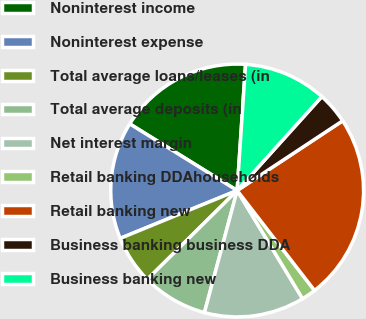Convert chart to OTSL. <chart><loc_0><loc_0><loc_500><loc_500><pie_chart><fcel>Noninterest income<fcel>Noninterest expense<fcel>Total average loans/leases (in<fcel>Total average deposits (in<fcel>Net interest margin<fcel>Retail banking DDAhouseholds<fcel>Retail banking new<fcel>Business banking business DDA<fcel>Business banking new<nl><fcel>17.22%<fcel>15.02%<fcel>6.23%<fcel>8.42%<fcel>12.82%<fcel>1.83%<fcel>23.81%<fcel>4.03%<fcel>10.62%<nl></chart> 